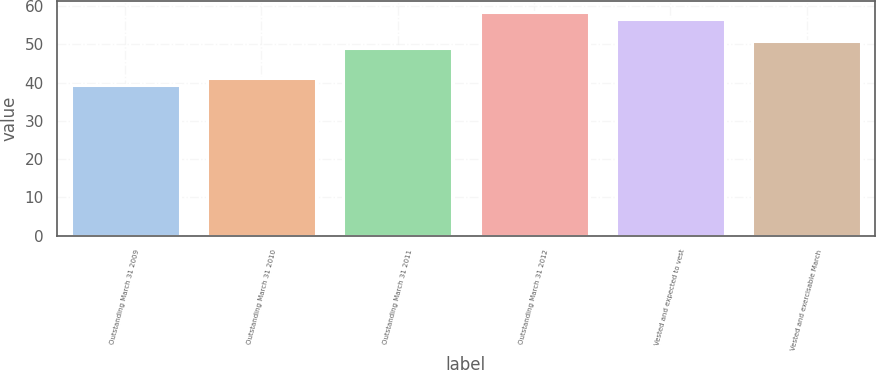<chart> <loc_0><loc_0><loc_500><loc_500><bar_chart><fcel>Outstanding March 31 2009<fcel>Outstanding March 31 2010<fcel>Outstanding March 31 2011<fcel>Outstanding March 31 2012<fcel>Vested and expected to vest<fcel>Vested and exercisable March<nl><fcel>39.28<fcel>41.26<fcel>49.01<fcel>58.47<fcel>56.71<fcel>50.77<nl></chart> 